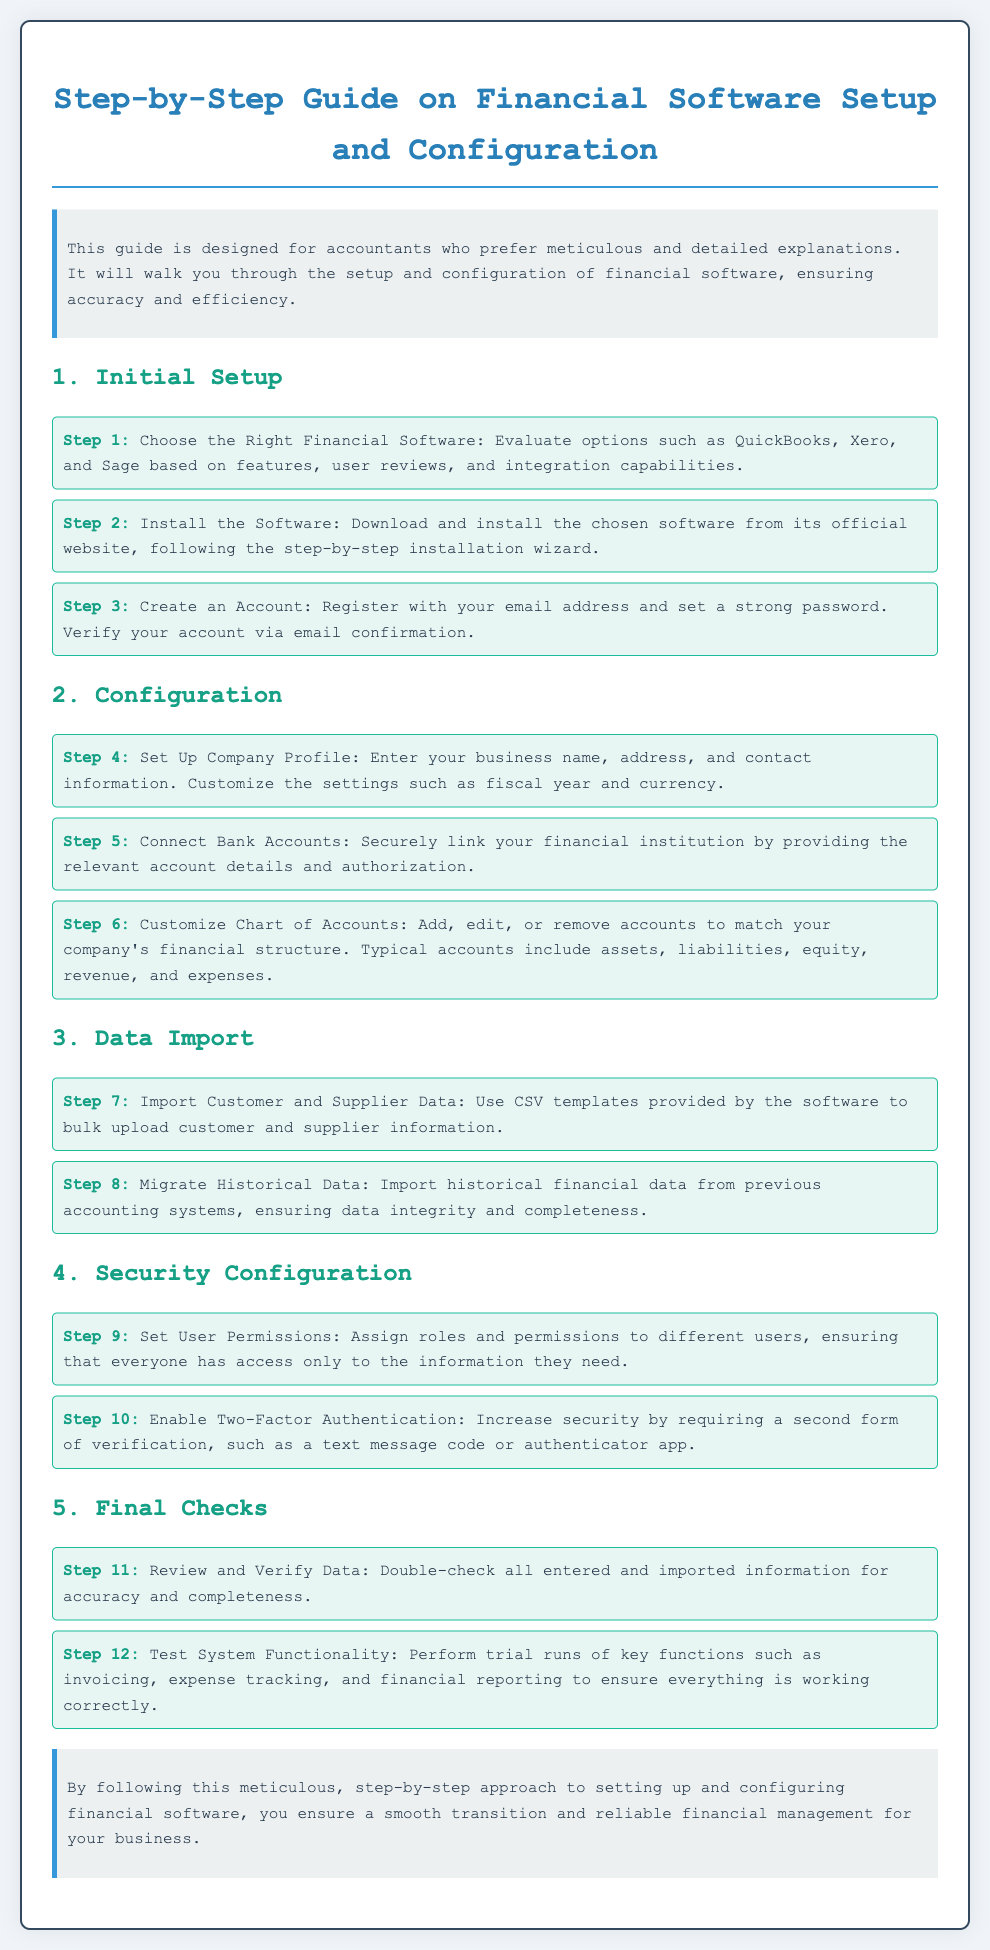What is the title of the document? The title of the document is prominently displayed at the top and provides a clear indication of the content focus.
Answer: Step-by-Step Guide on Financial Software Setup and Configuration Who is the target audience for this guide? The introduction specifies that the guide is intended for a particular audience, which helps to clarify the intended users of the information.
Answer: Accountants What is the first step of the initial setup? The first step listed under the Initial Setup section provides a clear directive for users to start the setup process.
Answer: Choose the Right Financial Software How many steps are in the configuration section? The number of steps in the configuration section is indicated by the individual listed steps, helping users to understand the complexity of the setup process.
Answer: Three What should you do in Step 9? This step provides a specific action related to security configuration, indicating the actions required for effective software usage.
Answer: Set User Permissions What is emphasized in the conclusion? The conclusion summarizes the overall importance of following the guide meticulously, providing its significance to the reader.
Answer: Smooth transition How is the document styled? The question focuses on the design aspects of the document, indicating the effort put into its presentation and readability.
Answer: Monospace font Which step involves two-factor authentication? This question connects a specific feature to its corresponding step, highlighting the importance of security measures in the software setup.
Answer: Step 10 What should you do before final checks? This question relates to the final preparations before completing the setup process, indicating an essential part of the workflow.
Answer: Review and Verify Data 